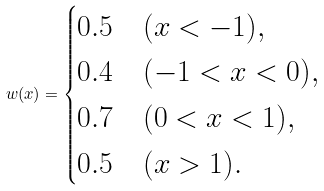Convert formula to latex. <formula><loc_0><loc_0><loc_500><loc_500>w ( x ) = \begin{cases} 0 . 5 & ( x < - 1 ) , \\ 0 . 4 & ( - 1 < x < 0 ) , \\ 0 . 7 & ( 0 < x < 1 ) , \\ 0 . 5 & ( x > 1 ) . \end{cases}</formula> 